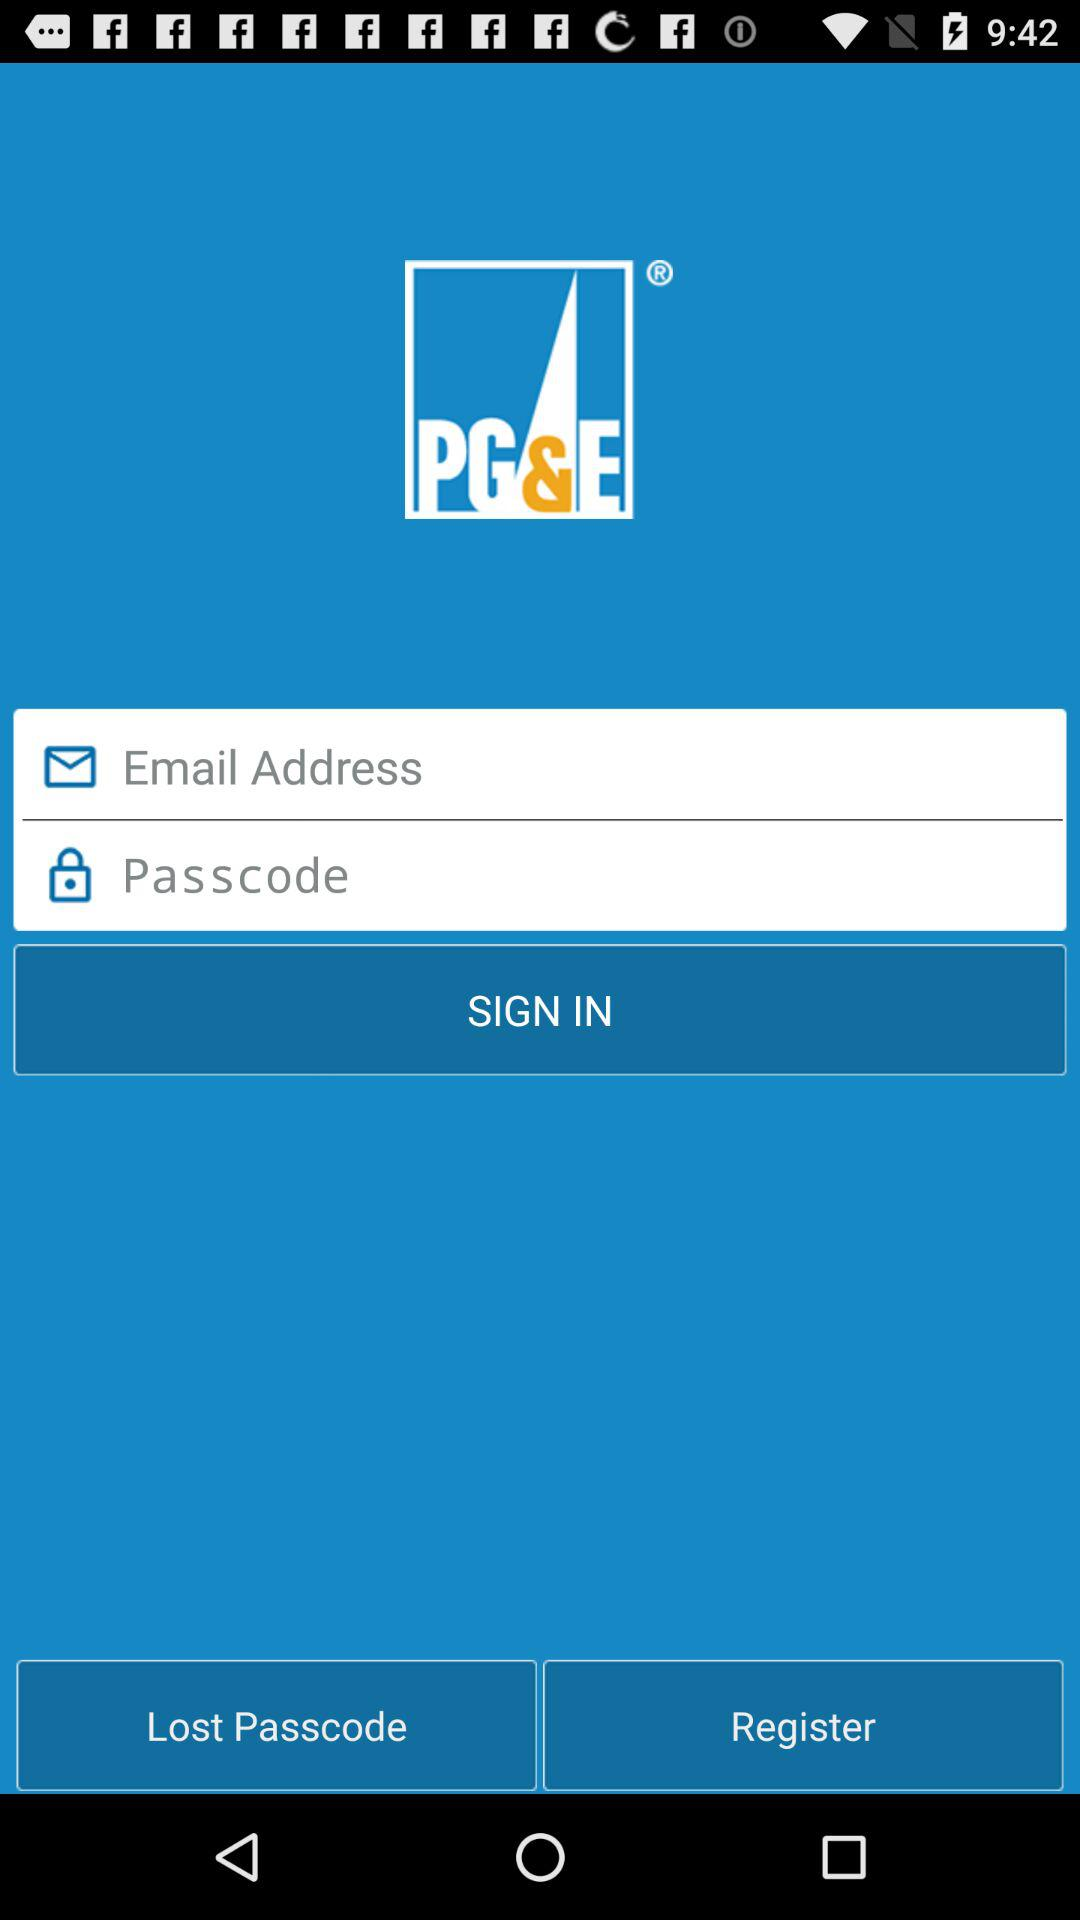How many input fields are there for sign in?
Answer the question using a single word or phrase. 2 